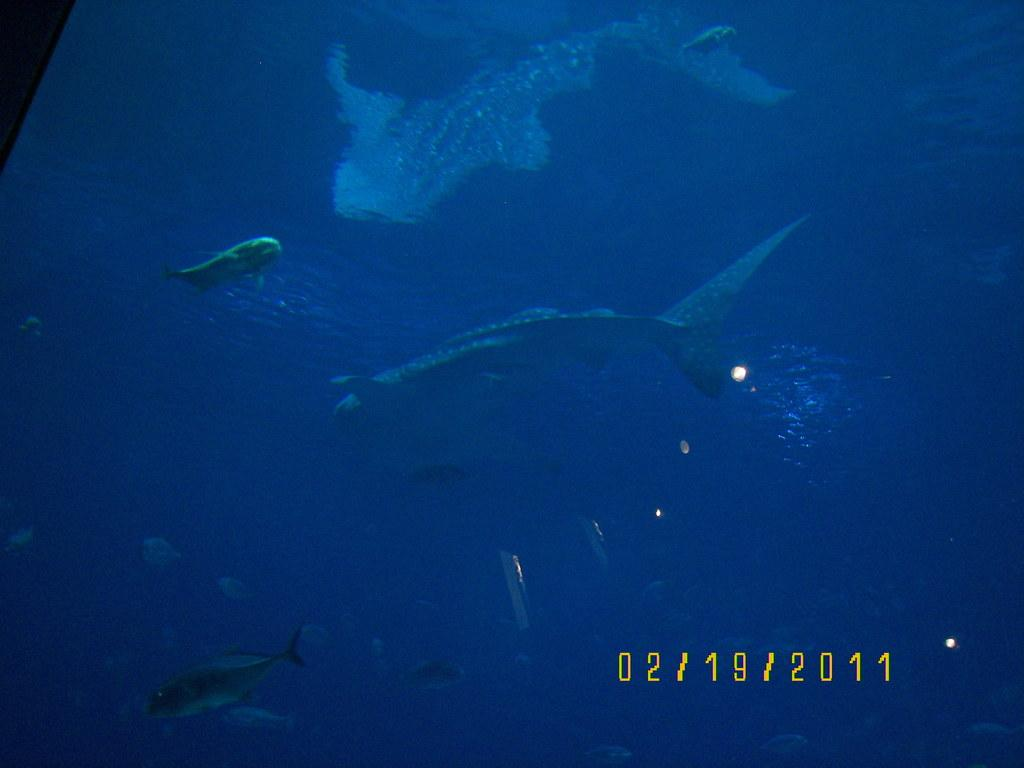What type of marine animals can be seen in the image? There are sharks and fishes in the water. Can you tell me more about the date at the bottom of the image? Unfortunately, the provided facts do not give any information about the date at the bottom of the image. What is the primary element in which the sharks and fishes are situated? The sharks and fishes are situated in the water. How many brothers are swimming with the sharks in the image? There are no brothers swimming with the sharks in the image; it only features sharks and fishes in the water. What type of dinosaurs can be seen in the image? There are no dinosaurs present in the image; it only features sharks and fishes in the water. 